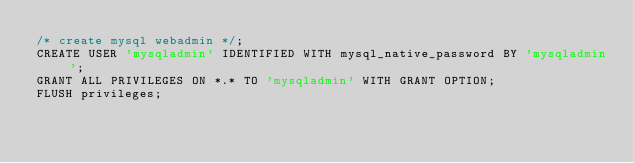<code> <loc_0><loc_0><loc_500><loc_500><_SQL_>/* create mysql webadmin */;
CREATE USER 'mysqladmin' IDENTIFIED WITH mysql_native_password BY 'mysqladmin';
GRANT ALL PRIVILEGES ON *.* TO 'mysqladmin' WITH GRANT OPTION;
FLUSH privileges;
</code> 